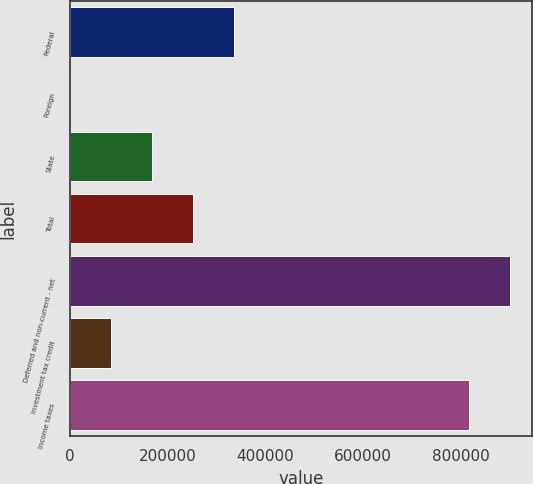<chart> <loc_0><loc_0><loc_500><loc_500><bar_chart><fcel>Federal<fcel>Foreign<fcel>State<fcel>Total<fcel>Deferred and non-current - net<fcel>Investment tax credit<fcel>Income taxes<nl><fcel>336227<fcel>68<fcel>168147<fcel>252187<fcel>901299<fcel>84107.7<fcel>817259<nl></chart> 